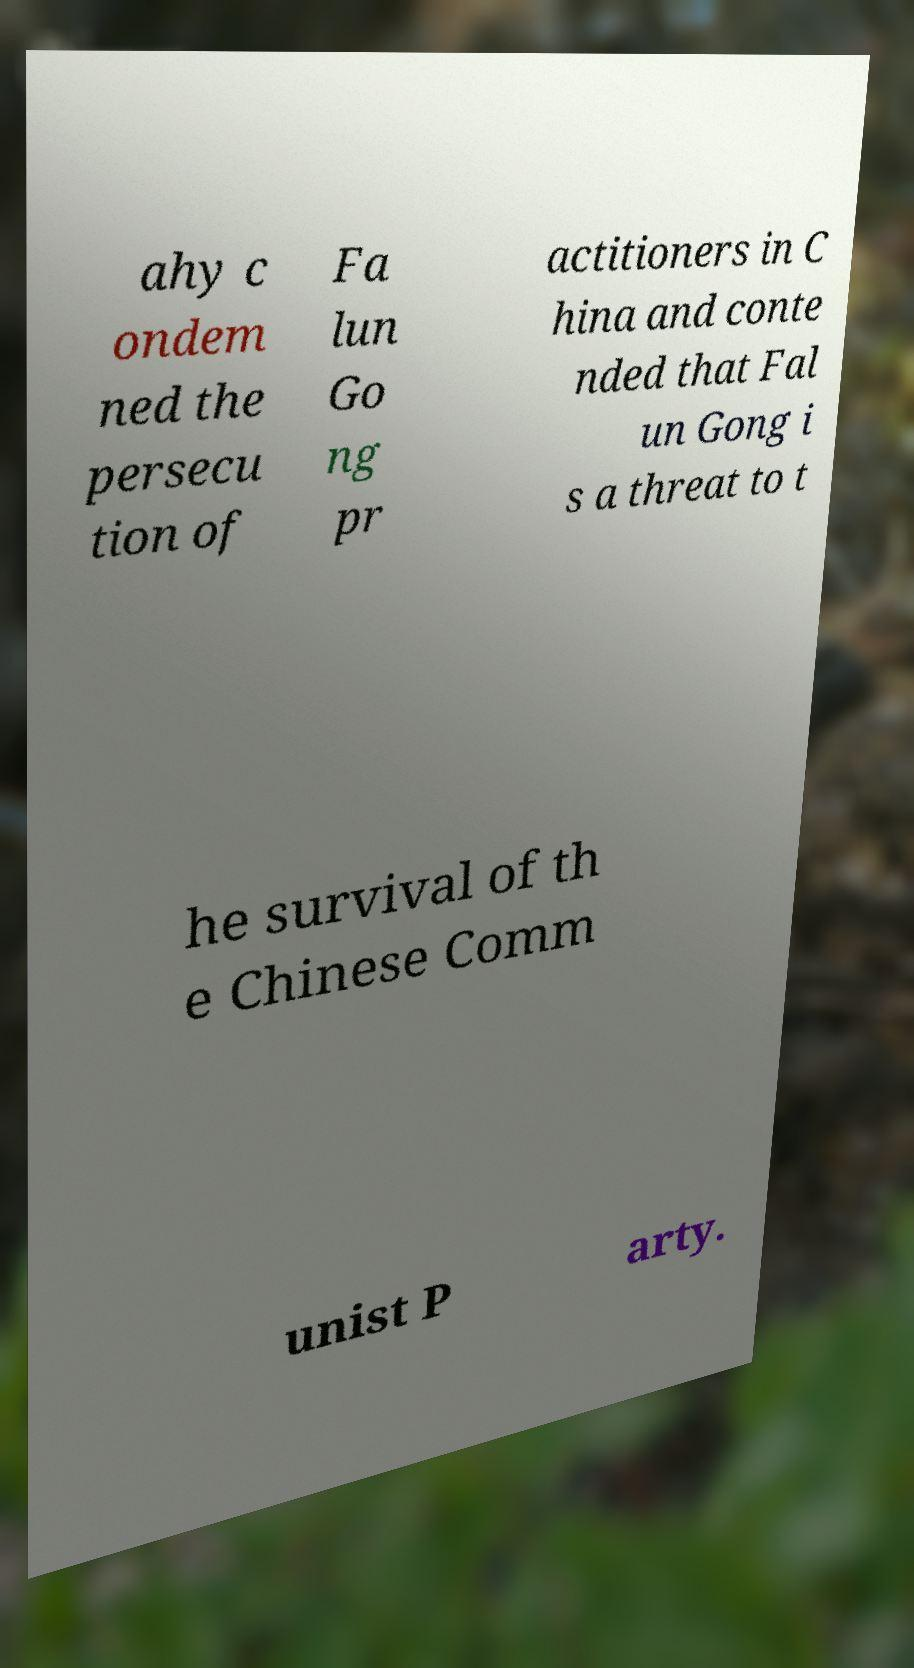I need the written content from this picture converted into text. Can you do that? ahy c ondem ned the persecu tion of Fa lun Go ng pr actitioners in C hina and conte nded that Fal un Gong i s a threat to t he survival of th e Chinese Comm unist P arty. 